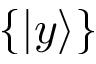<formula> <loc_0><loc_0><loc_500><loc_500>\{ | y \rangle \}</formula> 